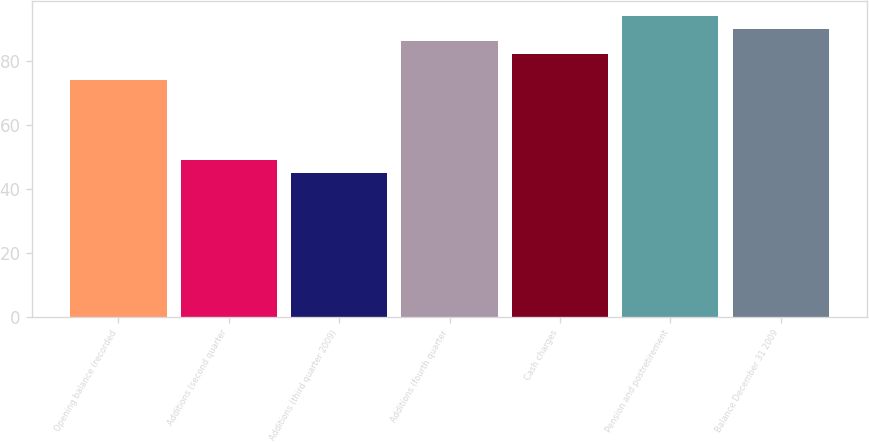<chart> <loc_0><loc_0><loc_500><loc_500><bar_chart><fcel>Opening balance (recorded<fcel>Additions (second quarter<fcel>Additions (third quarter 2009)<fcel>Additions (fourth quarter<fcel>Cash charges<fcel>Pension and postretirement<fcel>Balance December 31 2009<nl><fcel>74<fcel>49<fcel>45<fcel>86<fcel>82<fcel>94<fcel>90<nl></chart> 